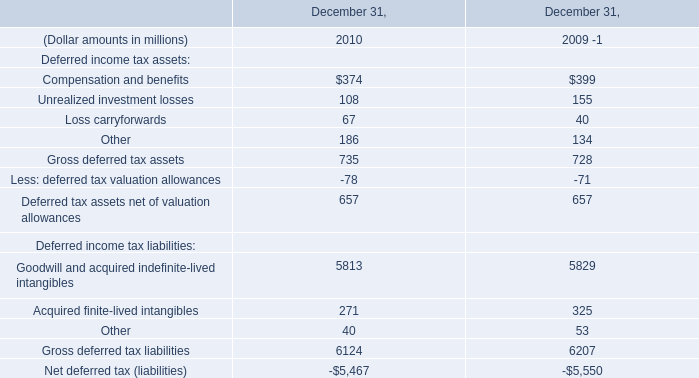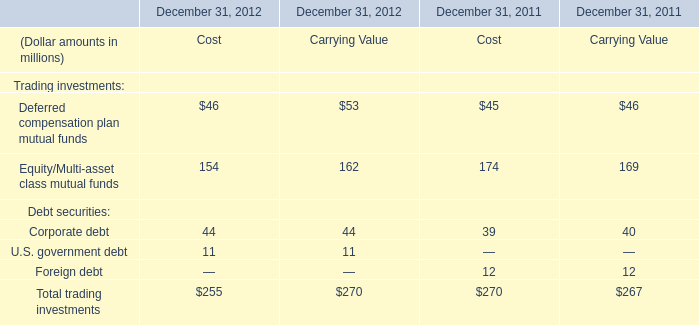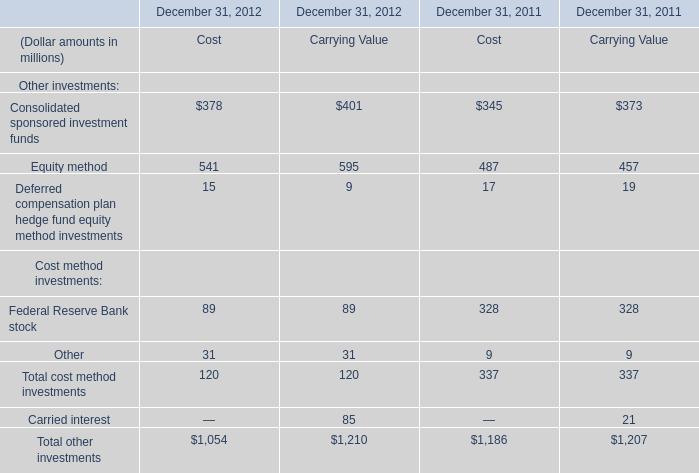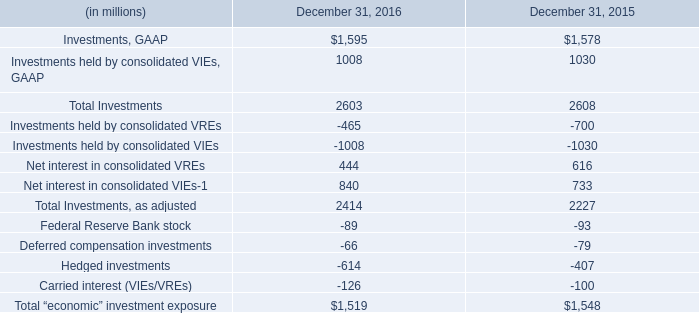What's the sum of Equity method in 2012? (in million) 
Computations: (541 + 595)
Answer: 1136.0. 